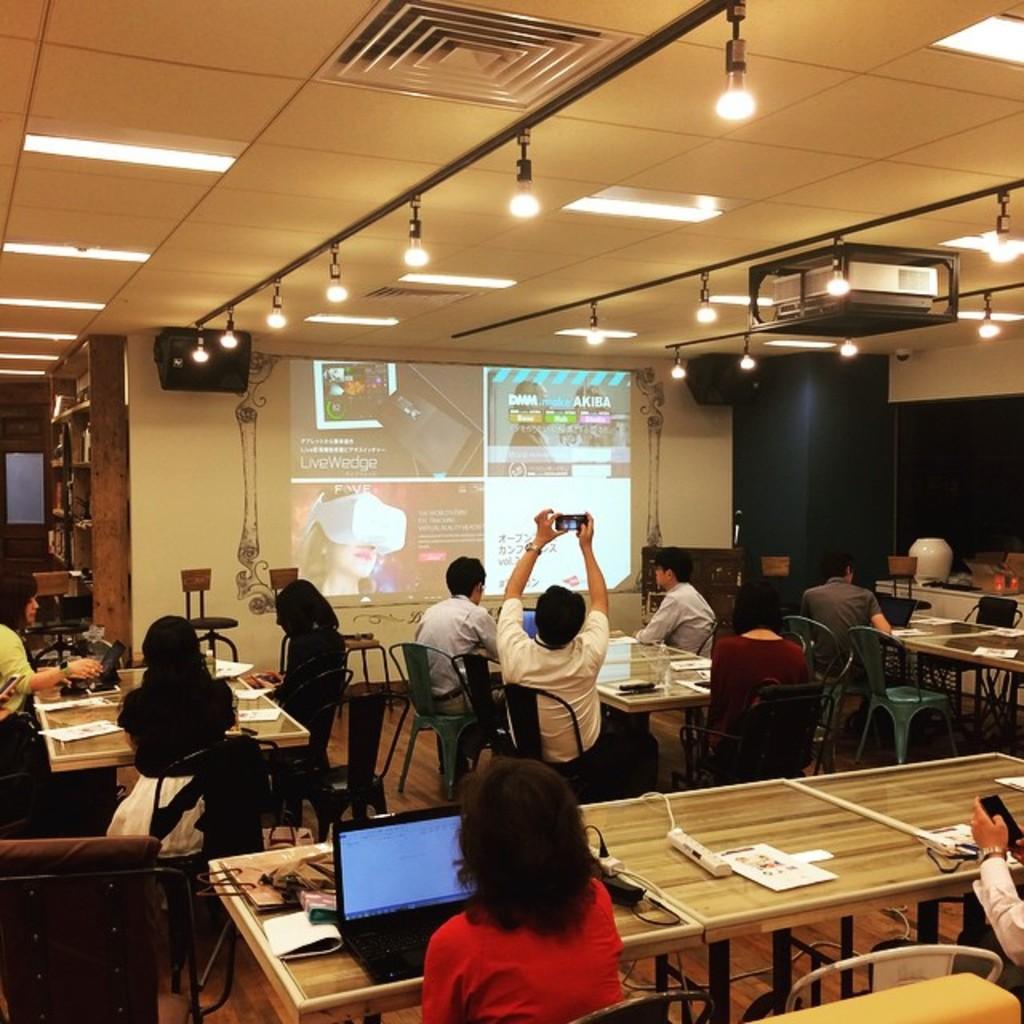In one or two sentences, can you explain what this image depicts? In this picture there are some people sitting on the chairs in front of the table on which there are some things and there is a projector screen and some lights and speakers. 